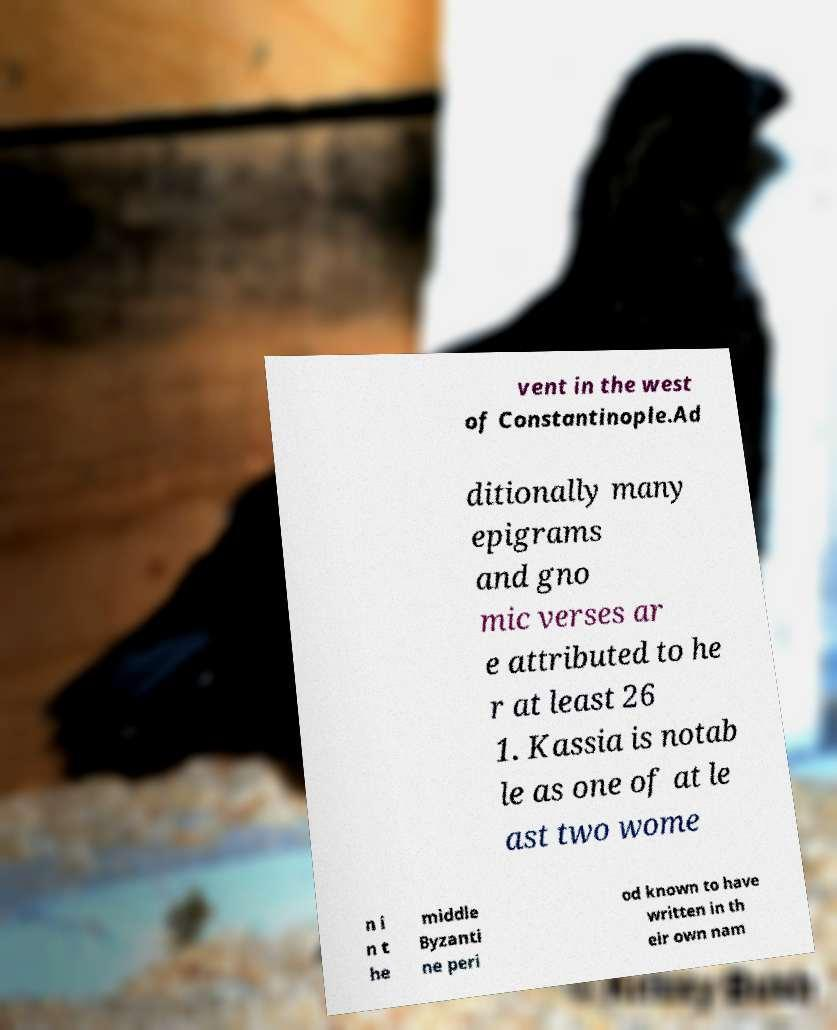Can you accurately transcribe the text from the provided image for me? vent in the west of Constantinople.Ad ditionally many epigrams and gno mic verses ar e attributed to he r at least 26 1. Kassia is notab le as one of at le ast two wome n i n t he middle Byzanti ne peri od known to have written in th eir own nam 